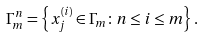Convert formula to latex. <formula><loc_0><loc_0><loc_500><loc_500>\Gamma _ { m } ^ { n } = \left \{ x _ { j } ^ { ( i ) } \in \Gamma _ { m } \colon n \leq i \leq m \right \} .</formula> 